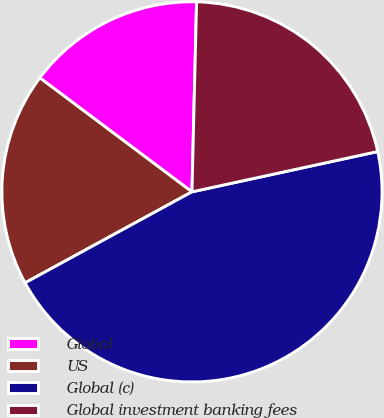Convert chart to OTSL. <chart><loc_0><loc_0><loc_500><loc_500><pie_chart><fcel>Global<fcel>US<fcel>Global (c)<fcel>Global investment banking fees<nl><fcel>15.15%<fcel>18.18%<fcel>45.45%<fcel>21.21%<nl></chart> 